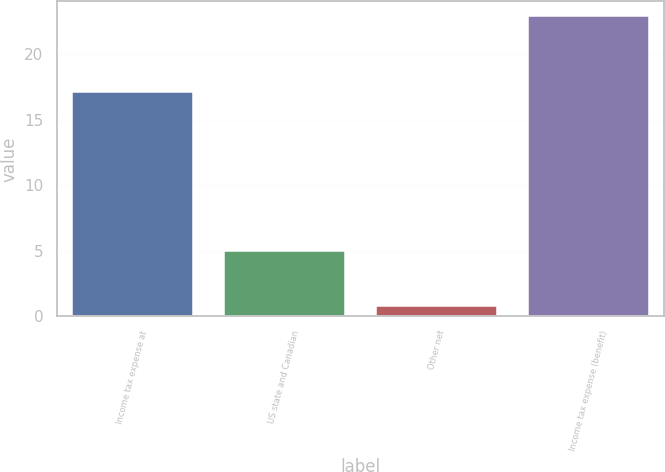Convert chart. <chart><loc_0><loc_0><loc_500><loc_500><bar_chart><fcel>Income tax expense at<fcel>US state and Canadian<fcel>Other net<fcel>Income tax expense (benefit)<nl><fcel>17.1<fcel>5<fcel>0.8<fcel>22.9<nl></chart> 